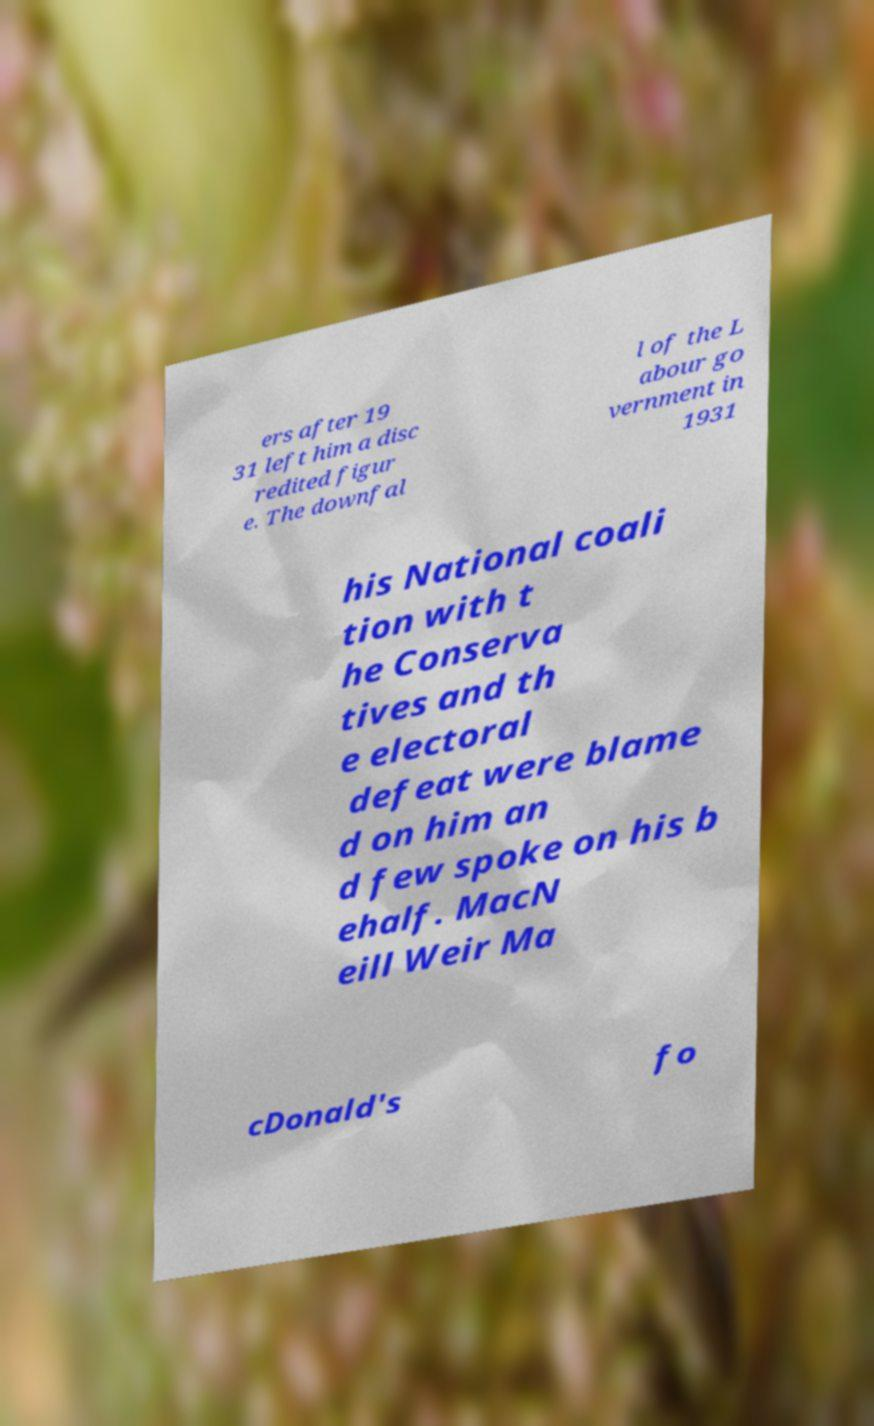Please identify and transcribe the text found in this image. ers after 19 31 left him a disc redited figur e. The downfal l of the L abour go vernment in 1931 his National coali tion with t he Conserva tives and th e electoral defeat were blame d on him an d few spoke on his b ehalf. MacN eill Weir Ma cDonald's fo 